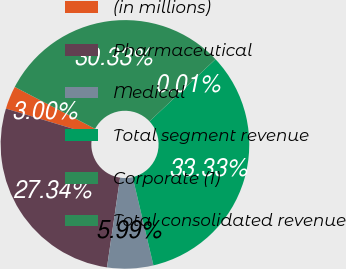Convert chart to OTSL. <chart><loc_0><loc_0><loc_500><loc_500><pie_chart><fcel>(in millions)<fcel>Pharmaceutical<fcel>Medical<fcel>Total segment revenue<fcel>Corporate (1)<fcel>Total consolidated revenue<nl><fcel>3.0%<fcel>27.34%<fcel>5.99%<fcel>33.33%<fcel>0.01%<fcel>30.33%<nl></chart> 